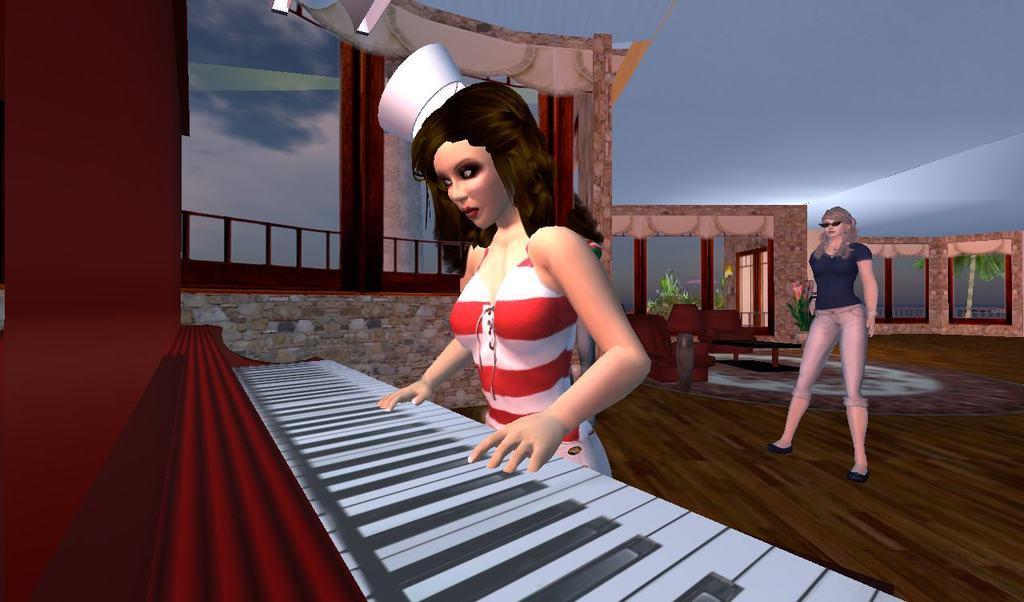Can you describe this image briefly? It is a cartoon image. In the image in the center, we can see two persons are standing and we can see one piano, table, fence and plants. In the background we can see the sky and clouds. 